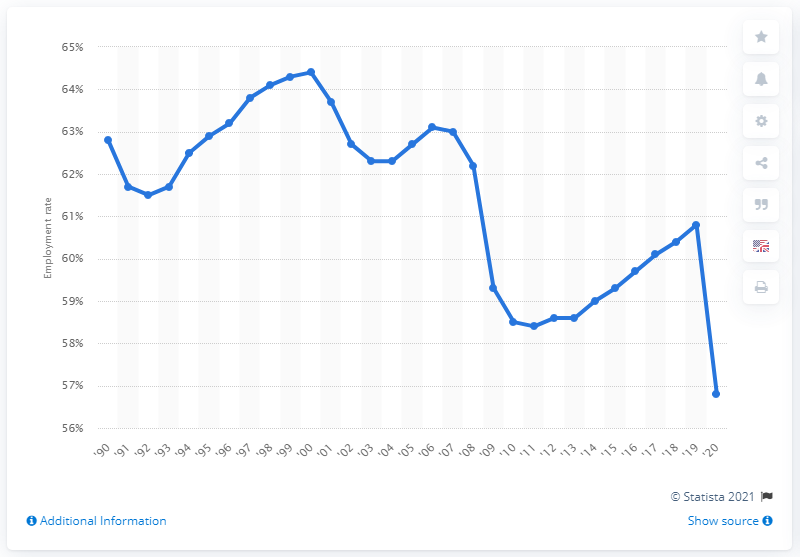Draw attention to some important aspects in this diagram. The U.S. employment rate in 2020 was 56.8%. 